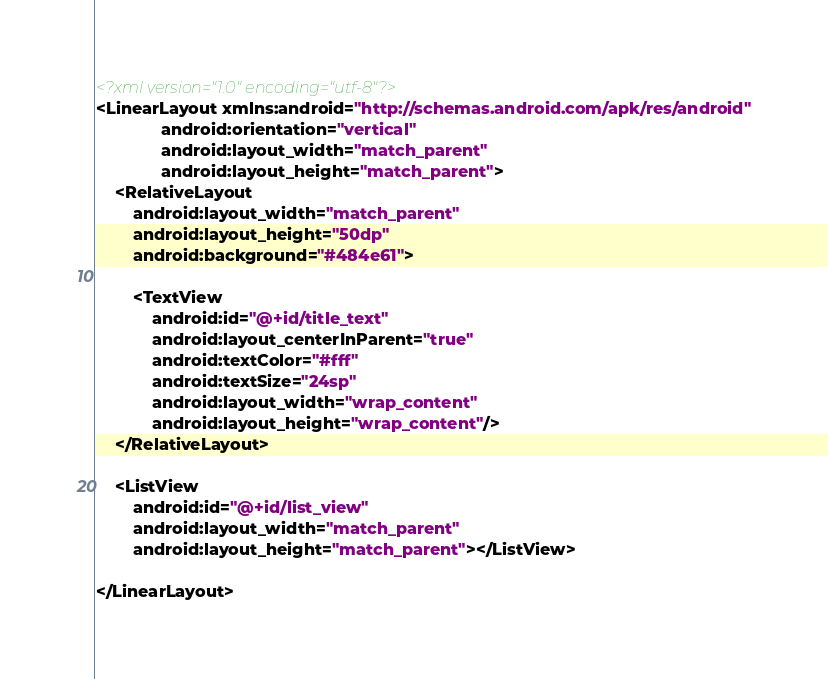<code> <loc_0><loc_0><loc_500><loc_500><_XML_><?xml version="1.0" encoding="utf-8"?>
<LinearLayout xmlns:android="http://schemas.android.com/apk/res/android"
              android:orientation="vertical"
              android:layout_width="match_parent"
              android:layout_height="match_parent">
    <RelativeLayout
        android:layout_width="match_parent"
        android:layout_height="50dp"
        android:background="#484e61">

        <TextView
            android:id="@+id/title_text"
            android:layout_centerInParent="true"
            android:textColor="#fff"
            android:textSize="24sp"
            android:layout_width="wrap_content"
            android:layout_height="wrap_content"/>
    </RelativeLayout>

    <ListView
        android:id="@+id/list_view"
        android:layout_width="match_parent"
        android:layout_height="match_parent"></ListView>

</LinearLayout></code> 